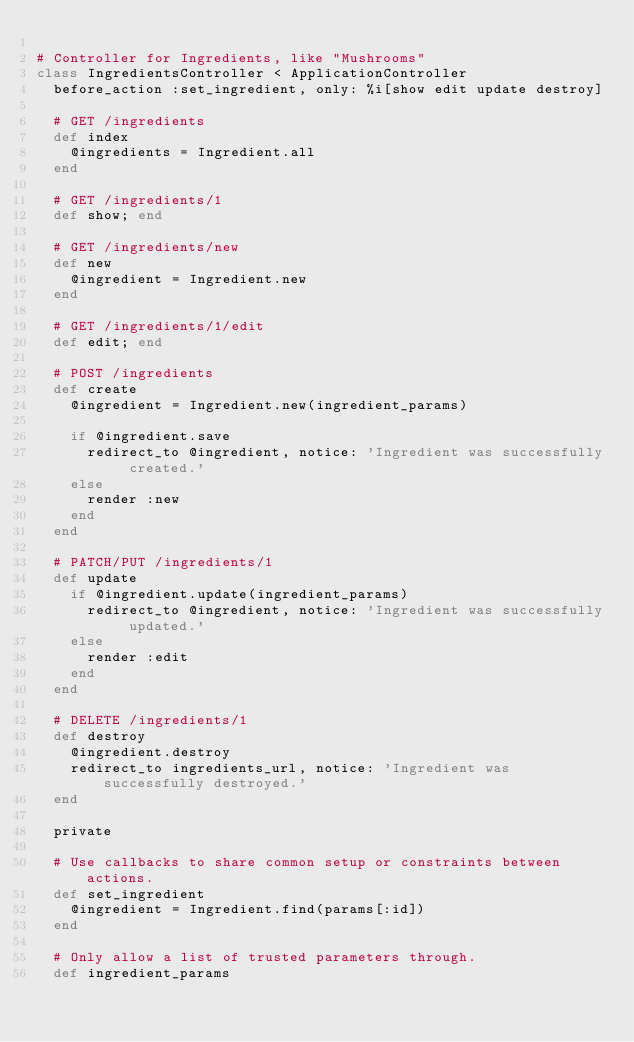<code> <loc_0><loc_0><loc_500><loc_500><_Ruby_>
# Controller for Ingredients, like "Mushrooms"
class IngredientsController < ApplicationController
  before_action :set_ingredient, only: %i[show edit update destroy]

  # GET /ingredients
  def index
    @ingredients = Ingredient.all
  end

  # GET /ingredients/1
  def show; end

  # GET /ingredients/new
  def new
    @ingredient = Ingredient.new
  end

  # GET /ingredients/1/edit
  def edit; end

  # POST /ingredients
  def create
    @ingredient = Ingredient.new(ingredient_params)

    if @ingredient.save
      redirect_to @ingredient, notice: 'Ingredient was successfully created.'
    else
      render :new
    end
  end

  # PATCH/PUT /ingredients/1
  def update
    if @ingredient.update(ingredient_params)
      redirect_to @ingredient, notice: 'Ingredient was successfully updated.'
    else
      render :edit
    end
  end

  # DELETE /ingredients/1
  def destroy
    @ingredient.destroy
    redirect_to ingredients_url, notice: 'Ingredient was successfully destroyed.'
  end

  private

  # Use callbacks to share common setup or constraints between actions.
  def set_ingredient
    @ingredient = Ingredient.find(params[:id])
  end

  # Only allow a list of trusted parameters through.
  def ingredient_params</code> 